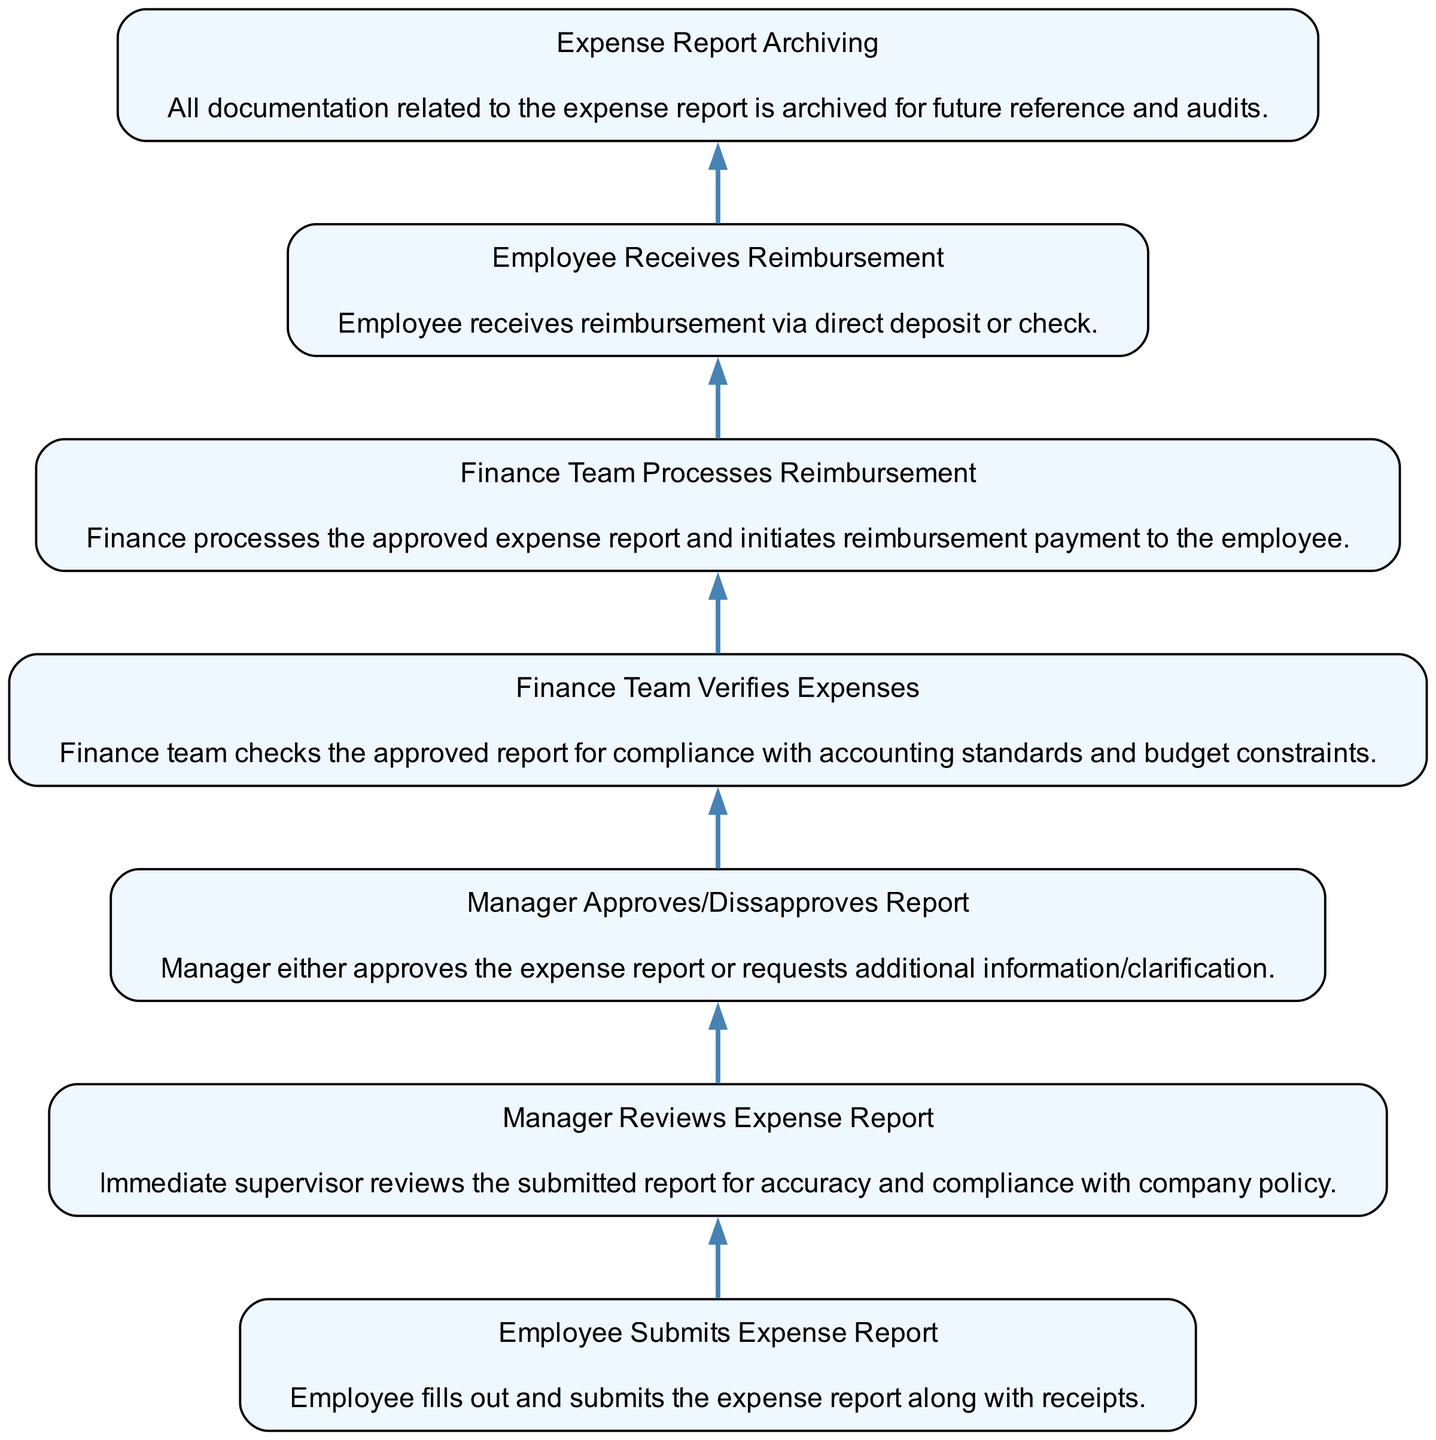What is the first step in the expense reimbursement workflow? The diagram indicates that the first step is the "Employee Submits Expense Report." This is the initial action taken by the employee where the expense report and receipts are filled out and submitted.
Answer: Employee Submits Expense Report How many steps are there in the process? By counting the elements within the diagram, we see that there are a total of seven distinct steps in the expense reimbursement workflow.
Answer: Seven What does the manager do after reviewing the expense report? The diagram shows that after reviewing, the manager either approves or disapproves the report. This is depicted as the next step following the review process.
Answer: Manager Approves/Dissapproves Report In which step does the finance team verify the expenses? According to the diagram, the finance team verifies the expenses at the "Finance Team Verifies Expenses" step, which follows the manager's approval step.
Answer: Finance Team Verifies Expenses What is the outcome after the finance team processes the reimbursement? The outcome after processing reimbursement is that the employee receives it. This is shown as the next step following the finance team's processing actions.
Answer: Employee Receives Reimbursement What documentation is archived, and why? The diagram indicates that "Expense Report Archiving" takes place, where all documentation related to the expense report is archived for future reference and audits.
Answer: All documentation related to the expense report What is the relationship between the manager reviewing the expense report and the finance team? The relationship is sequential; the manager's review must occur before the finance team can verify expenses, indicating a dependency in the workflow.
Answer: Sequential How does the employee receive reimbursement? The diagram states that employees receive reimbursement either via direct deposit or check. This detail is part of the reimbursement process described in the workflow.
Answer: Direct deposit or check What is necessary for the finance team to begin processing reimbursement? The finance team must first verify the expenses, which happens after the manager approves the report. This verifies compliance with standards before reimbursement is processed.
Answer: Approved expense report 